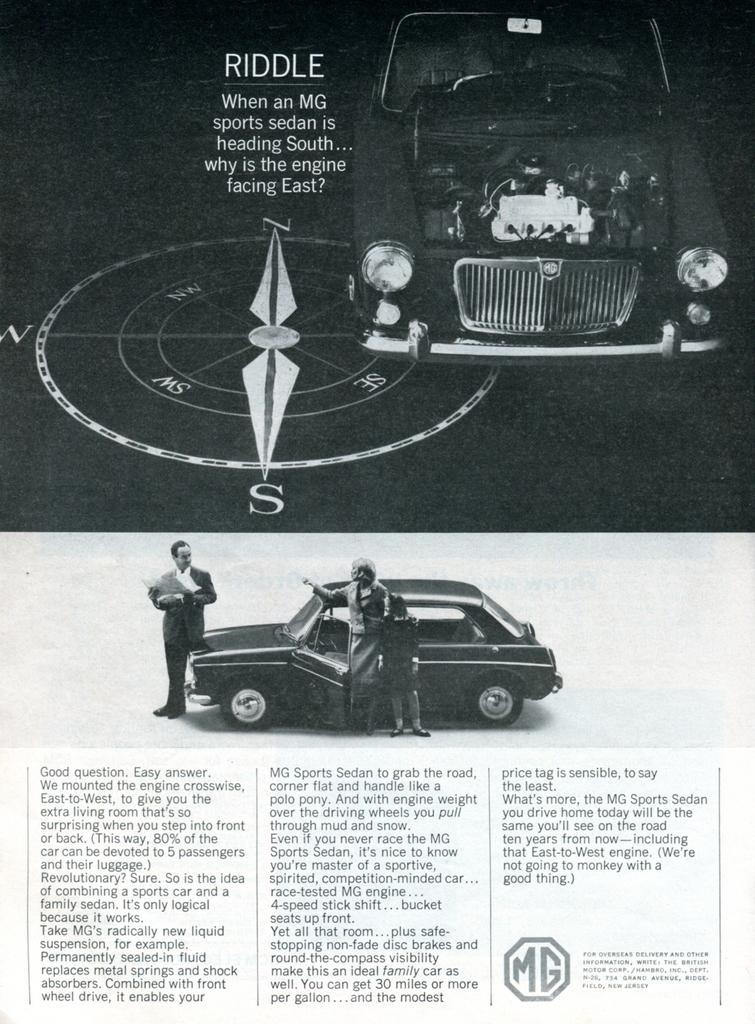In one or two sentences, can you explain what this image depicts? In this image we can see texts are written at the bottom and in the middle we can see three persons are standing at the car and at the top we can see a compass, car and texts written on the image. 